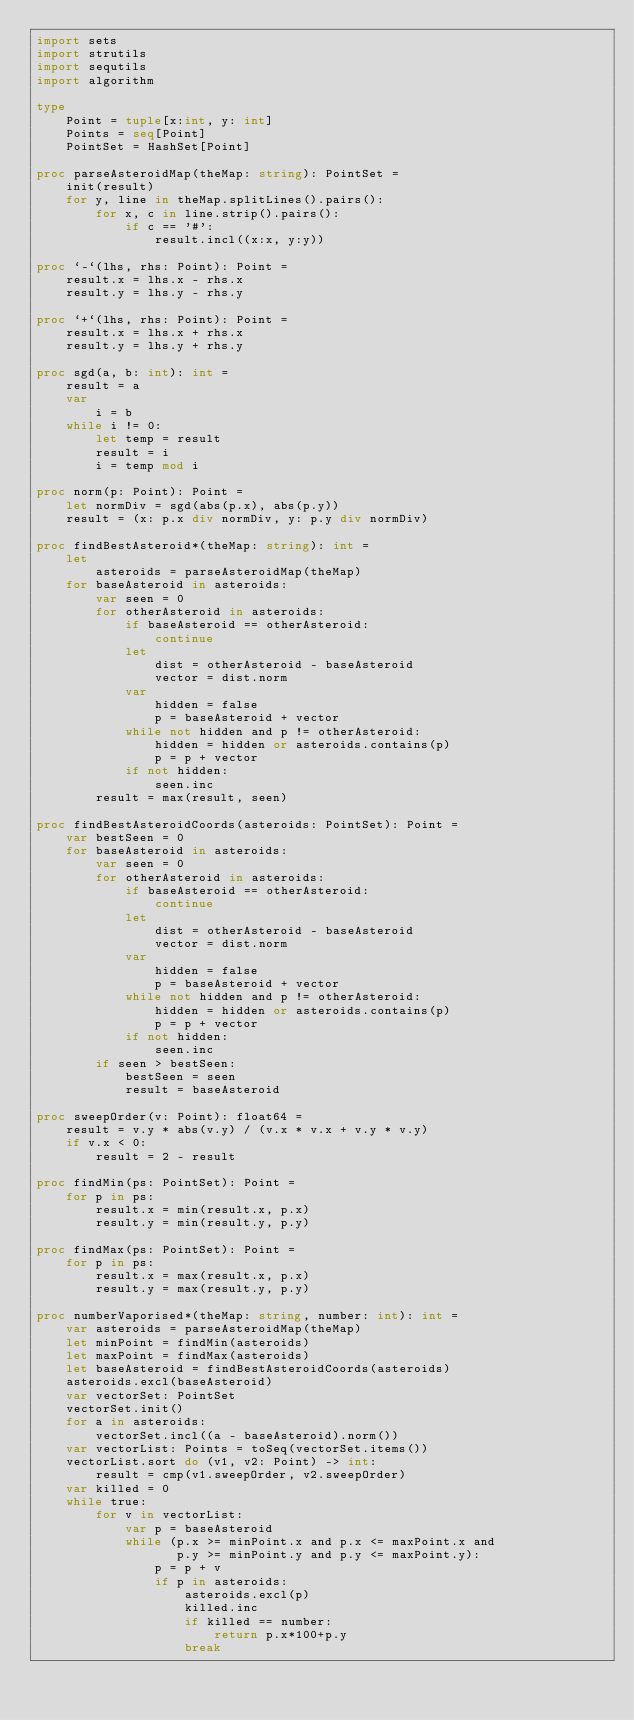<code> <loc_0><loc_0><loc_500><loc_500><_Nim_>import sets
import strutils
import sequtils
import algorithm

type
    Point = tuple[x:int, y: int]
    Points = seq[Point]
    PointSet = HashSet[Point] 

proc parseAsteroidMap(theMap: string): PointSet =
    init(result) 
    for y, line in theMap.splitLines().pairs():
        for x, c in line.strip().pairs():
            if c == '#':
                result.incl((x:x, y:y))

proc `-`(lhs, rhs: Point): Point =
    result.x = lhs.x - rhs.x
    result.y = lhs.y - rhs.y

proc `+`(lhs, rhs: Point): Point =
    result.x = lhs.x + rhs.x
    result.y = lhs.y + rhs.y

proc sgd(a, b: int): int =
    result = a
    var
        i = b
    while i != 0:
        let temp = result
        result = i
        i = temp mod i

proc norm(p: Point): Point =
    let normDiv = sgd(abs(p.x), abs(p.y))
    result = (x: p.x div normDiv, y: p.y div normDiv)

proc findBestAsteroid*(theMap: string): int =
    let
        asteroids = parseAsteroidMap(theMap)
    for baseAsteroid in asteroids:
        var seen = 0
        for otherAsteroid in asteroids:
            if baseAsteroid == otherAsteroid:
                continue
            let
                dist = otherAsteroid - baseAsteroid
                vector = dist.norm
            var
                hidden = false
                p = baseAsteroid + vector
            while not hidden and p != otherAsteroid:
                hidden = hidden or asteroids.contains(p)
                p = p + vector
            if not hidden:
                seen.inc
        result = max(result, seen)

proc findBestAsteroidCoords(asteroids: PointSet): Point =
    var bestSeen = 0
    for baseAsteroid in asteroids:
        var seen = 0
        for otherAsteroid in asteroids:
            if baseAsteroid == otherAsteroid:
                continue
            let
                dist = otherAsteroid - baseAsteroid
                vector = dist.norm
            var
                hidden = false
                p = baseAsteroid + vector
            while not hidden and p != otherAsteroid:
                hidden = hidden or asteroids.contains(p)
                p = p + vector
            if not hidden:
                seen.inc
        if seen > bestSeen:
            bestSeen = seen
            result = baseAsteroid

proc sweepOrder(v: Point): float64 =
    result = v.y * abs(v.y) / (v.x * v.x + v.y * v.y)
    if v.x < 0:
        result = 2 - result

proc findMin(ps: PointSet): Point =
    for p in ps:
        result.x = min(result.x, p.x)
        result.y = min(result.y, p.y)

proc findMax(ps: PointSet): Point =
    for p in ps:
        result.x = max(result.x, p.x)
        result.y = max(result.y, p.y)
        
proc numberVaporised*(theMap: string, number: int): int =
    var asteroids = parseAsteroidMap(theMap)
    let minPoint = findMin(asteroids)
    let maxPoint = findMax(asteroids)
    let baseAsteroid = findBestAsteroidCoords(asteroids)
    asteroids.excl(baseAsteroid)
    var vectorSet: PointSet
    vectorSet.init()
    for a in asteroids:
        vectorSet.incl((a - baseAsteroid).norm())
    var vectorList: Points = toSeq(vectorSet.items())
    vectorList.sort do (v1, v2: Point) -> int:
        result = cmp(v1.sweepOrder, v2.sweepOrder)
    var killed = 0
    while true:
        for v in vectorList:
            var p = baseAsteroid
            while (p.x >= minPoint.x and p.x <= maxPoint.x and 
                   p.y >= minPoint.y and p.y <= maxPoint.y):
                p = p + v
                if p in asteroids:
                    asteroids.excl(p)
                    killed.inc
                    if killed == number:
                        return p.x*100+p.y
                    break</code> 